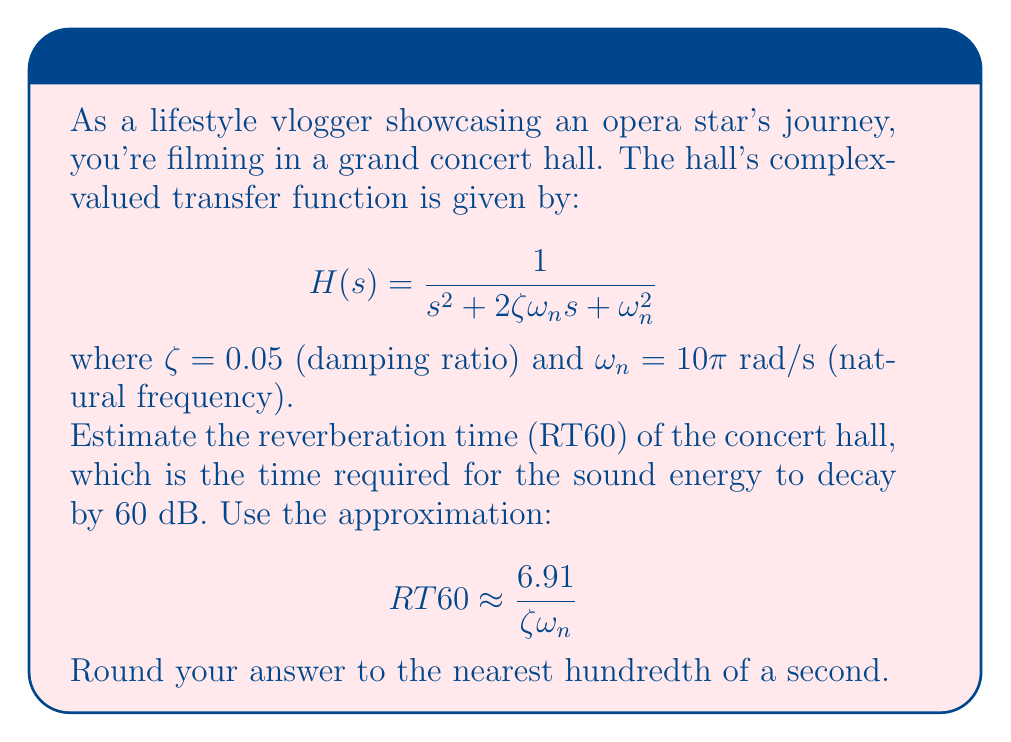Provide a solution to this math problem. To estimate the reverberation time (RT60) of the concert hall, we'll follow these steps:

1) We're given the approximation formula:
   $$RT60 \approx \frac{6.91}{\zeta\omega_n}$$

2) We know:
   $\zeta = 0.05$ (damping ratio)
   $\omega_n = 10\pi$ rad/s (natural frequency)

3) Let's substitute these values into the formula:
   $$RT60 \approx \frac{6.91}{0.05 \cdot 10\pi}$$

4) Simplify:
   $$RT60 \approx \frac{6.91}{0.5\pi}$$

5) Calculate:
   $$RT60 \approx \frac{6.91}{1.5708} \approx 4.4011$$

6) Rounding to the nearest hundredth:
   $$RT60 \approx 4.40\text{ seconds}$$

This means that in this concert hall, it takes approximately 4.40 seconds for the sound energy to decay by 60 dB.
Answer: 4.40 seconds 